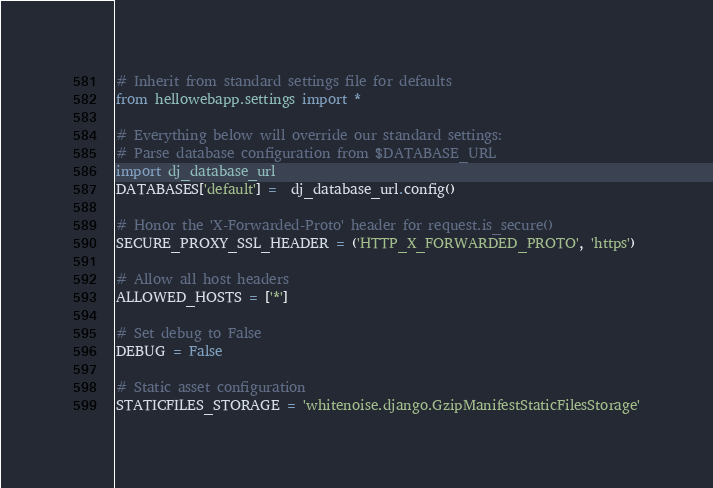<code> <loc_0><loc_0><loc_500><loc_500><_Python_># Inherit from standard settings file for defaults
from hellowebapp.settings import *

# Everything below will override our standard settings:
# Parse database configuration from $DATABASE_URL
import dj_database_url
DATABASES['default'] =  dj_database_url.config()

# Honor the 'X-Forwarded-Proto' header for request.is_secure()
SECURE_PROXY_SSL_HEADER = ('HTTP_X_FORWARDED_PROTO', 'https')

# Allow all host headers
ALLOWED_HOSTS = ['*']

# Set debug to False
DEBUG = False 

# Static asset configuration
STATICFILES_STORAGE = 'whitenoise.django.GzipManifestStaticFilesStorage'
</code> 